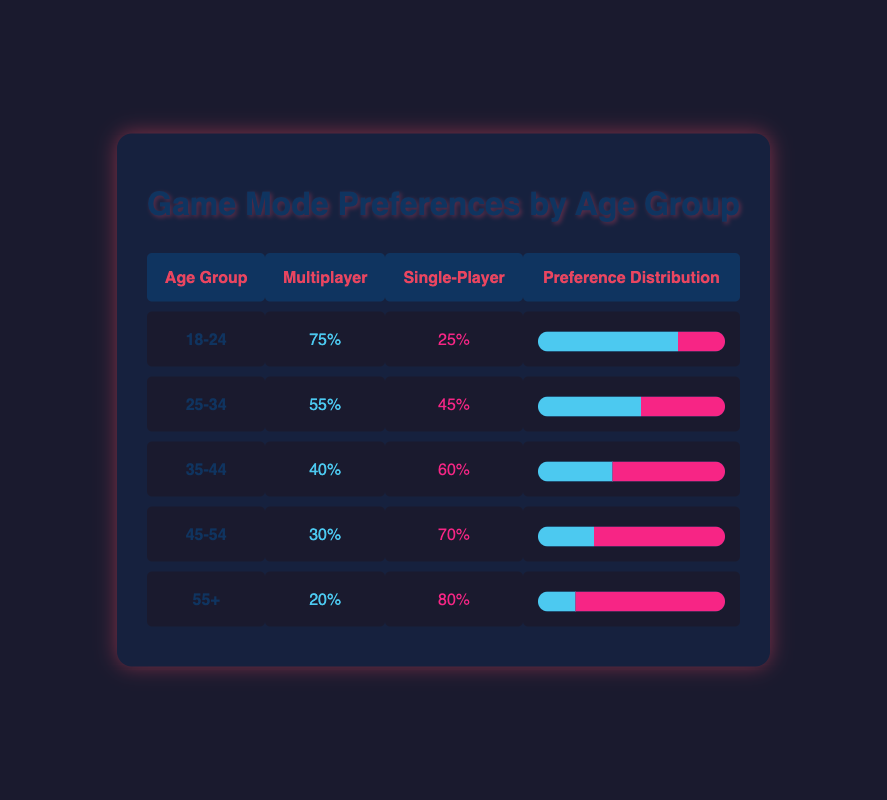What is the percentage of players in the 18-24 age group who prefer multiplayer games? According to the table, the percentage of players in the 18-24 age group who prefer multiplayer games is 75%.
Answer: 75% Which age group has the highest preference for single-player mode? The age group that has the highest preference for single-player mode is 55+, with 80% preferring this mode.
Answer: 55+ What is the average percentage of multiplayer preferences across all age groups? To find the average percentage of multiplayer preferences, we sum all the multiplayer percentages: 75 + 55 + 40 + 30 + 20 = 220, then divide by 5, resulting in an average of 44%.
Answer: 44% Is it true that players aged 35-44 prefer single-player games over multiplayer games? Yes, players aged 35-44 have a single-player preference of 60%, which is higher than their multiplayer preference of 40%.
Answer: Yes What is the difference in percentage between multiplayer and single-player preferences for the age group 25-34? For the 25-34 age group, the multiplayer preference is 55% and the single-player preference is 45%. The difference is 55% - 45% = 10%.
Answer: 10% Which age group shows the smallest difference between multiplayer and single-player preferences? The age group 25-34 shows the smallest difference with a 10% preference difference (55% multiplayer, 45% single-player).
Answer: 25-34 What percentage of the 45-54 age group prefers multiplayer mode? The percentage of the 45-54 age group that prefers multiplayer mode is 30%.
Answer: 30% Are there more players aged 55+ who prefer single-player games compared to those aged 18-24 who prefer multiplayer games? Yes, 80% of players aged 55+ prefer single-player games, which is higher than the 75% of players aged 18-24 who prefer multiplayer games.
Answer: Yes 